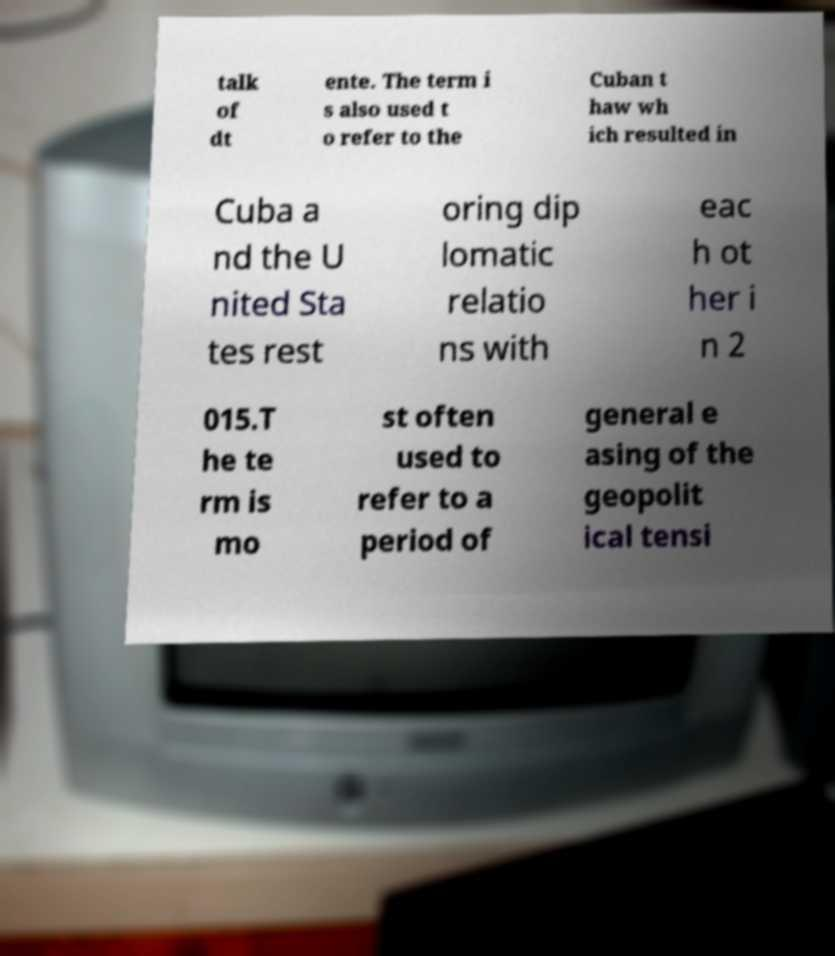Can you read and provide the text displayed in the image?This photo seems to have some interesting text. Can you extract and type it out for me? talk of dt ente. The term i s also used t o refer to the Cuban t haw wh ich resulted in Cuba a nd the U nited Sta tes rest oring dip lomatic relatio ns with eac h ot her i n 2 015.T he te rm is mo st often used to refer to a period of general e asing of the geopolit ical tensi 